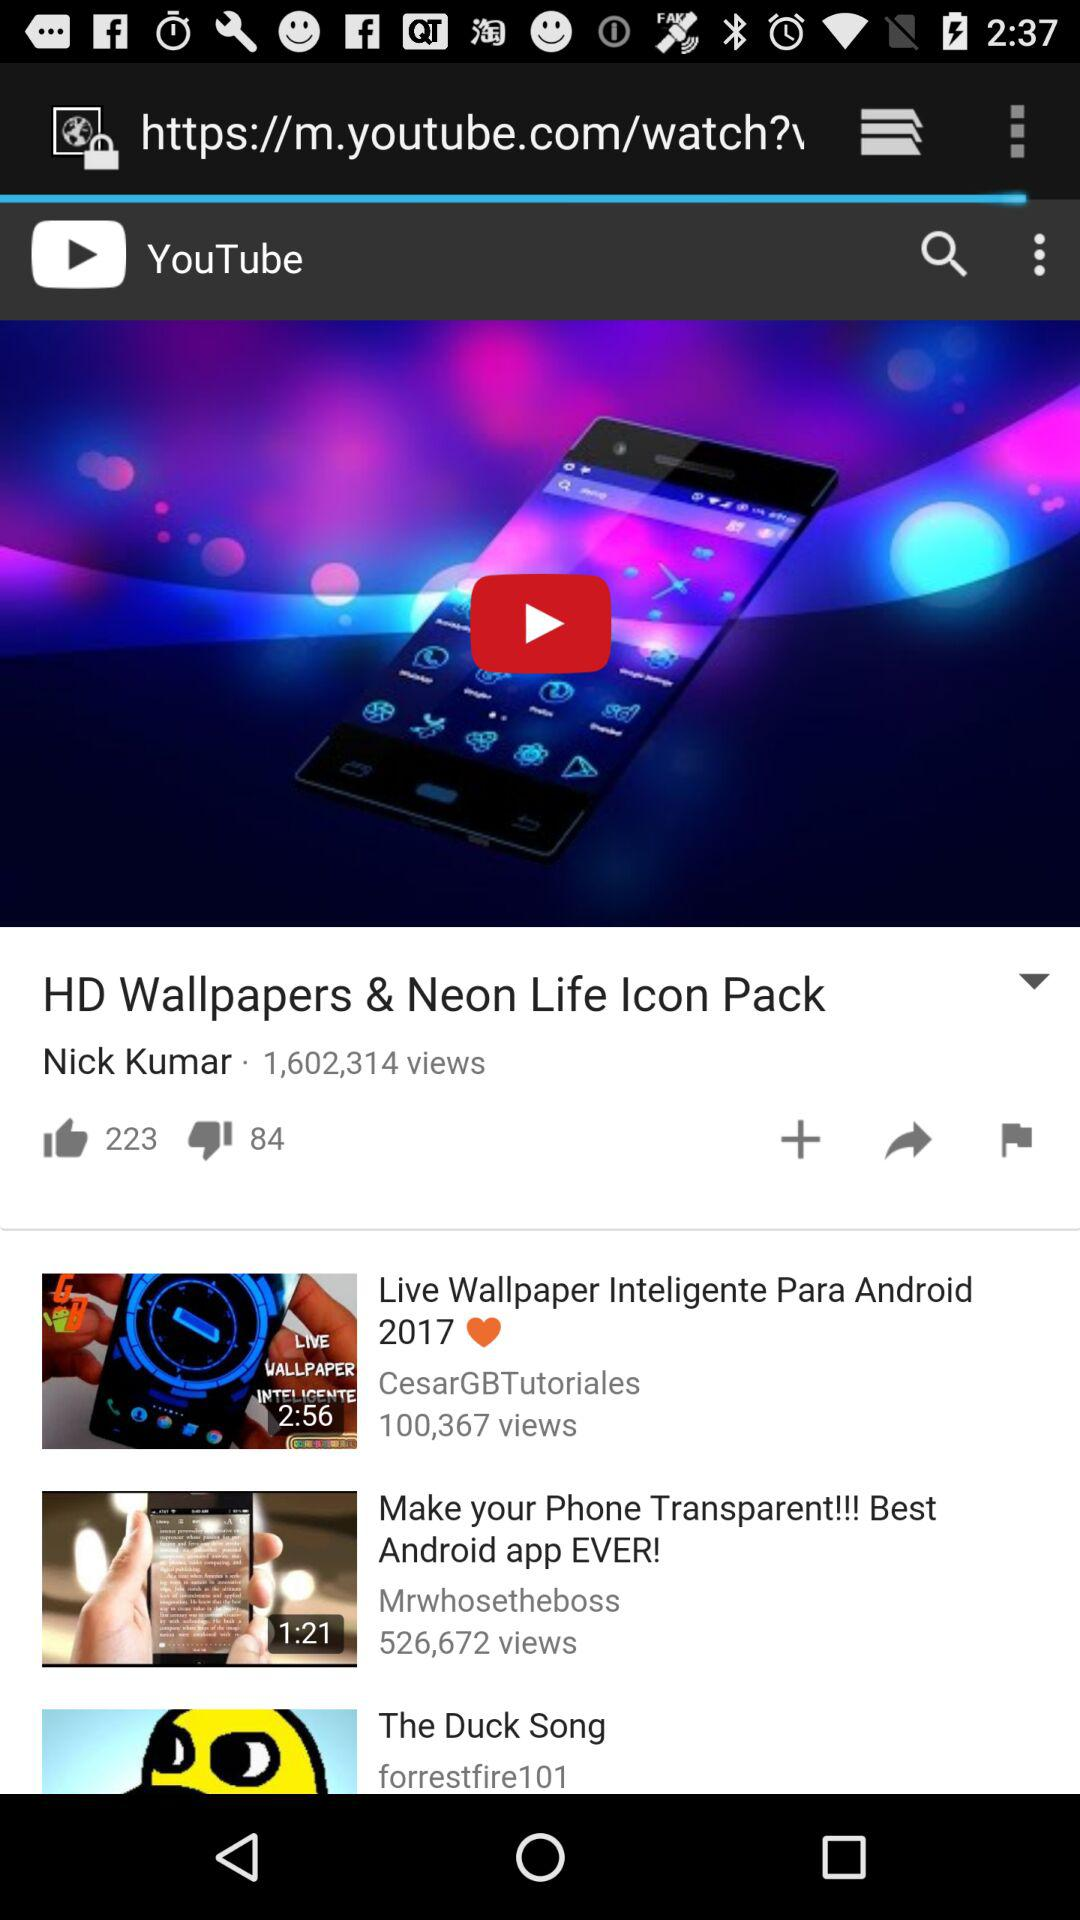How many views of "Live Wallpaper Inteligente Para Android 2017"? There are 100,367 views. 